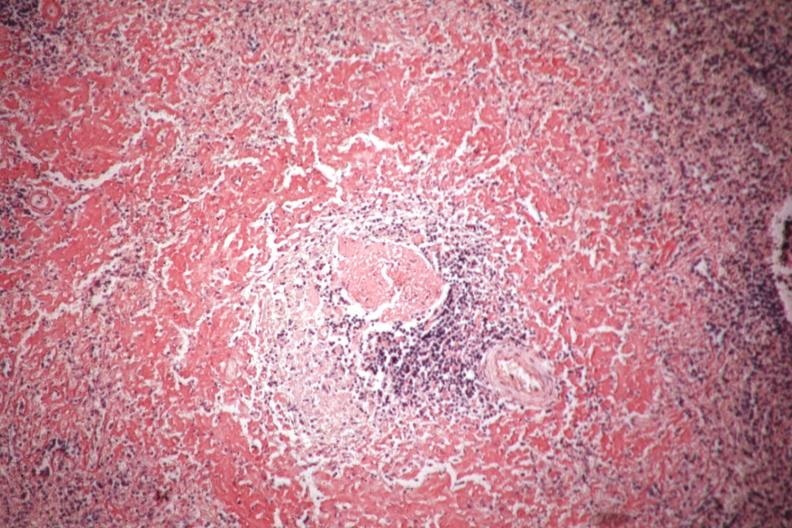s hematologic present?
Answer the question using a single word or phrase. No 